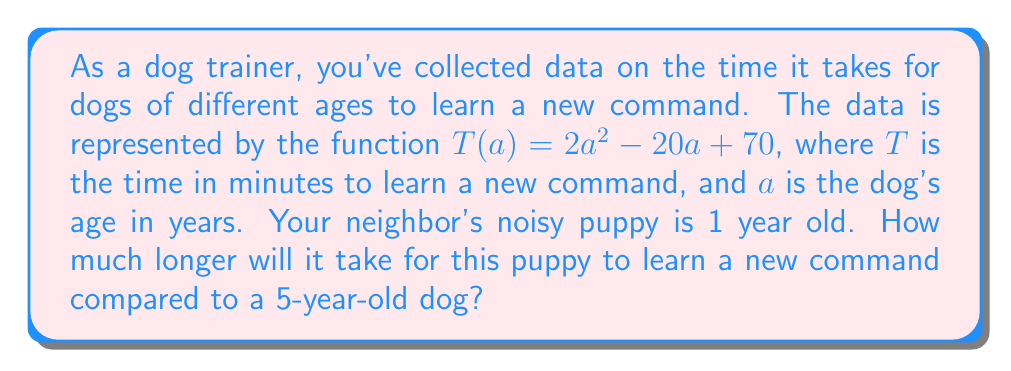Provide a solution to this math problem. To solve this problem, we need to follow these steps:

1) First, let's calculate the time it takes for a 1-year-old puppy to learn a new command:
   $T(1) = 2(1)^2 - 20(1) + 70 = 2 - 20 + 70 = 52$ minutes

2) Next, let's calculate the time for a 5-year-old dog:
   $T(5) = 2(5)^2 - 20(5) + 70 = 50 - 100 + 70 = 20$ minutes

3) To find how much longer it takes the puppy, we subtract:
   $52 - 20 = 32$ minutes

We can visualize this using a graph:

[asy]
import graph;
size(200,200);
real f(real x) {return 2x^2 - 20x + 70;}
draw(graph(f,0,10));
dot((1,f(1)),red);
dot((5,f(5)),blue);
label("1-year-old puppy",(1,f(1)),NE,red);
label("5-year-old dog",(5,f(5)),SE,blue);
xaxis("Age (years)",0,10,Arrow);
yaxis("Time to learn (minutes)",0,100,Arrow);
[/asy]

This graph shows the parabolic relationship between a dog's age and the time it takes to learn a new command. The red dot represents the 1-year-old puppy, while the blue dot represents the 5-year-old dog.
Answer: The 1-year-old puppy will take 32 minutes longer to learn a new command compared to a 5-year-old dog. 